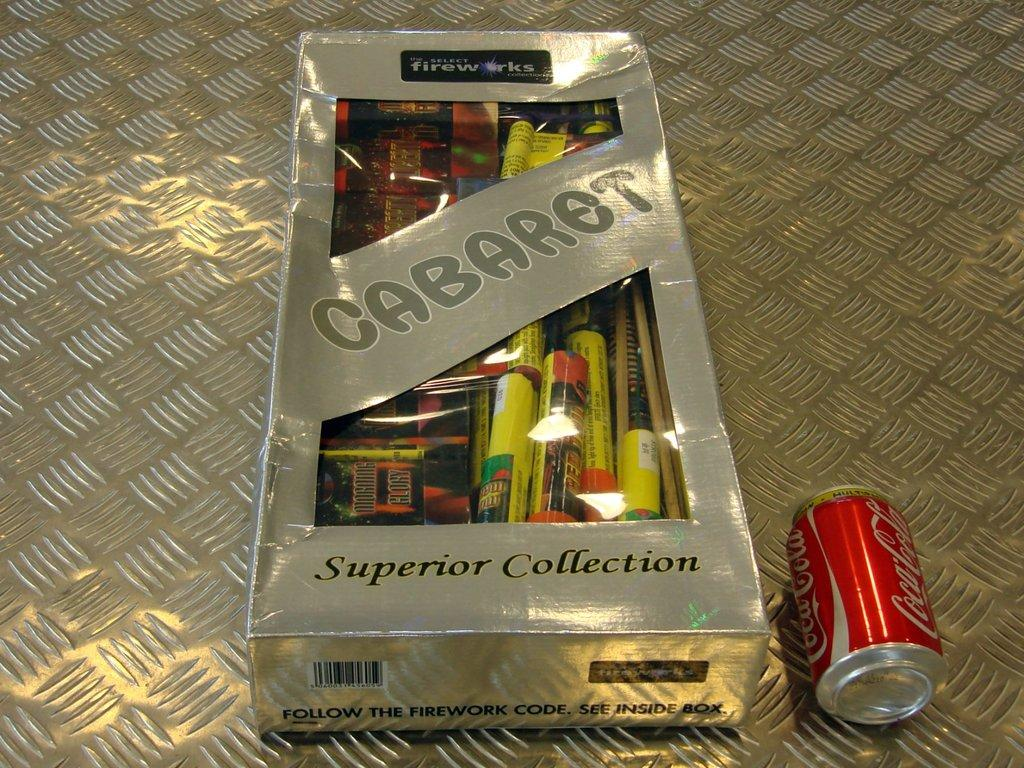What type of writing utensils are in the image? There are markers in a box in the image. Where is the coke tin located in the image? The coke tin is on the floor in the image. What type of tent is set up next to the markers in the image? There is no tent present in the image; it only features markers in a box and a coke tin on the floor. How many marks can be seen on the coke tin in the image? There are no marks visible on the coke tin in the image. 